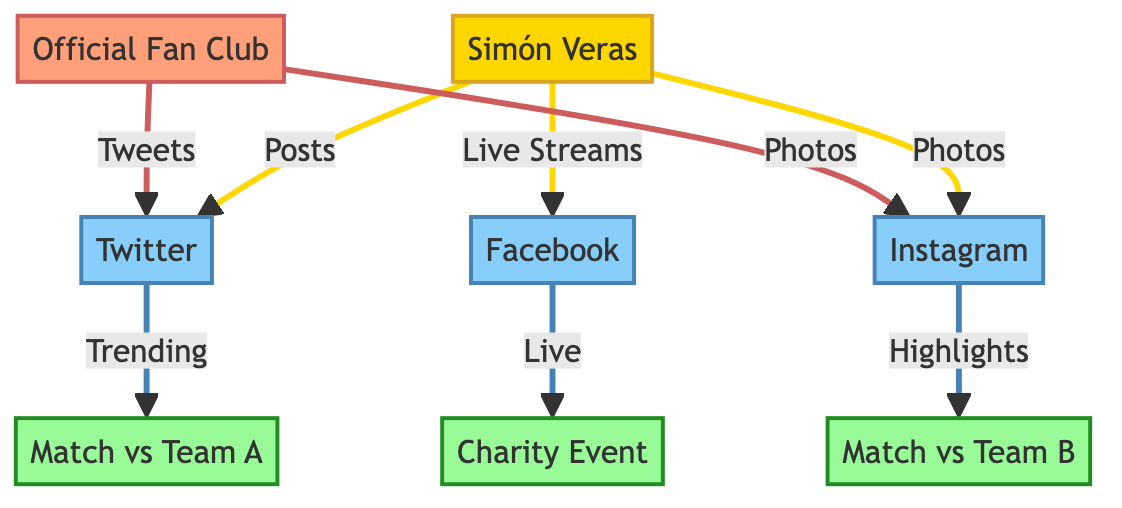What is the primary platform Simón Veras uses to post content? The diagram shows an arrow from Simón Veras to Twitter labeled "Posts," indicating that Twitter is the primary platform he uses to post content.
Answer: Twitter How many social media platforms are represented in the diagram? The diagram includes three distinct social media platforms: Twitter, Instagram, and Facebook, which can be counted directly.
Answer: 3 Which match is highlighted through Instagram? The diagram has an arrow from Instagram to "Match vs Team B" with the label "Highlights," showing that this match is highlighted on Instagram.
Answer: Match vs Team B What type of event is connected to Facebook in the diagram? There is an arrow from Facebook to "Charity Event" labeled "Live," indicating that the Charity Event is the type of event connected to Facebook.
Answer: Charity Event How many interactions do the Official Fan Club have with the platforms? The Official Fan Club interacts with both Twitter and Instagram, as shown by the links labeled "Tweets" and "Photos," totaling two interactions.
Answer: 2 Which event has a live streaming connection? The arrow labeled "Live" originates from Facebook and points to "Charity Event," indicating that this event has a live streaming connection.
Answer: Charity Event What is the relationship type between Simón Veras and Instagram? The relationship is defined by the arrow from Simón Veras to Instagram with the label "Photos," establishing the type of interaction as sharing photos.
Answer: Photos Which platform becomes trending during the match against Team A? The diagram shows an arrow from Twitter to "Match vs Team A" labeled "Trending," indicating that Twitter becomes trending during this match.
Answer: Twitter What type of group is the Official Fan Club classified as in the diagram? The Official Fan Club is classified under the group category, as indicated by its distinct color and the label "group" in the diagram.
Answer: Group 